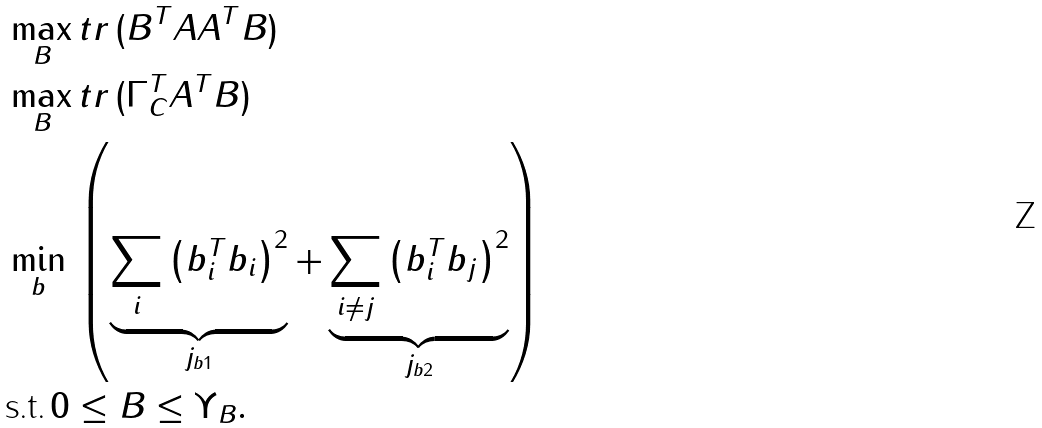<formula> <loc_0><loc_0><loc_500><loc_500>& \max _ { B } t r \, ( B ^ { T } A A ^ { T } B ) \\ & \max _ { B } t r \, ( \Gamma _ { C } ^ { T } A ^ { T } B ) \\ & \min _ { b } \, \left ( \underbrace { \sum _ { i } \left ( b _ { i } ^ { T } b _ { i } \right ) ^ { 2 } } _ { j _ { b 1 } } + \underbrace { \sum _ { i \ne j } \left ( b _ { i } ^ { T } b _ { j } \right ) ^ { 2 } } _ { j _ { b 2 } } \right ) \\ & \text {s.t.} \, 0 \leq B \leq \Upsilon _ { B } .</formula> 